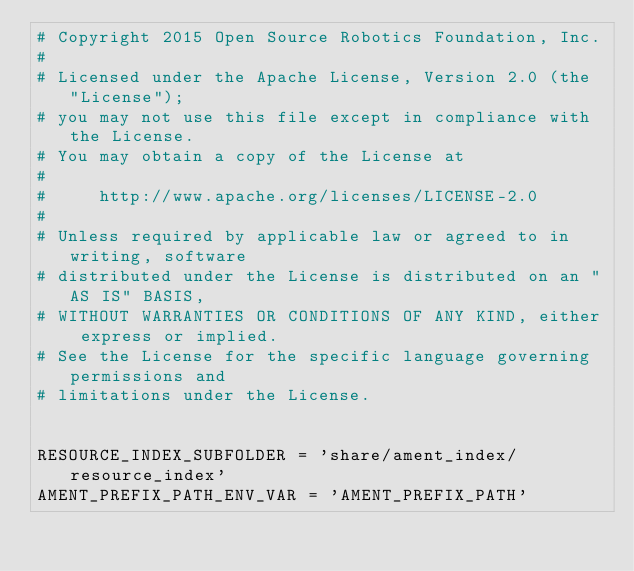Convert code to text. <code><loc_0><loc_0><loc_500><loc_500><_Python_># Copyright 2015 Open Source Robotics Foundation, Inc.
#
# Licensed under the Apache License, Version 2.0 (the "License");
# you may not use this file except in compliance with the License.
# You may obtain a copy of the License at
#
#     http://www.apache.org/licenses/LICENSE-2.0
#
# Unless required by applicable law or agreed to in writing, software
# distributed under the License is distributed on an "AS IS" BASIS,
# WITHOUT WARRANTIES OR CONDITIONS OF ANY KIND, either express or implied.
# See the License for the specific language governing permissions and
# limitations under the License.


RESOURCE_INDEX_SUBFOLDER = 'share/ament_index/resource_index'
AMENT_PREFIX_PATH_ENV_VAR = 'AMENT_PREFIX_PATH'
</code> 